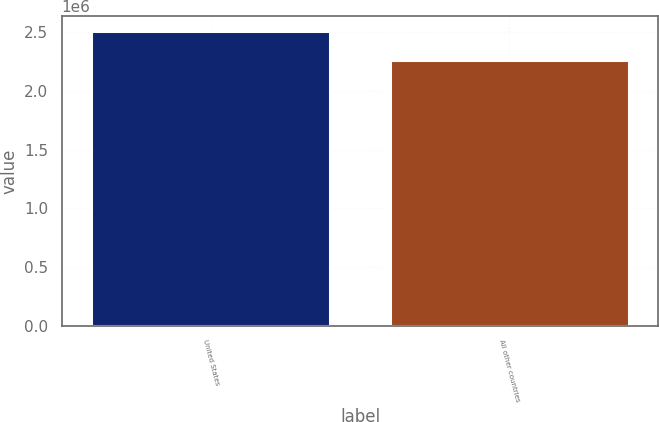<chart> <loc_0><loc_0><loc_500><loc_500><bar_chart><fcel>United States<fcel>All other countries<nl><fcel>2.51016e+06<fcel>2.2611e+06<nl></chart> 